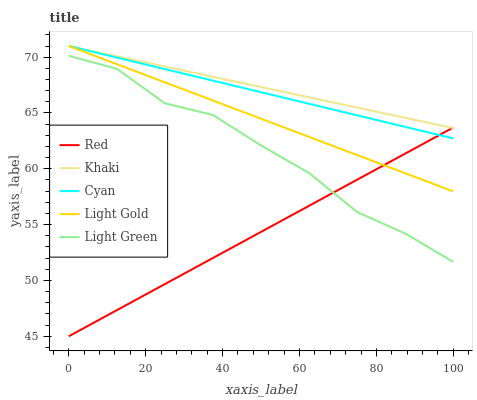Does Red have the minimum area under the curve?
Answer yes or no. Yes. Does Khaki have the maximum area under the curve?
Answer yes or no. Yes. Does Light Gold have the minimum area under the curve?
Answer yes or no. No. Does Light Gold have the maximum area under the curve?
Answer yes or no. No. Is Cyan the smoothest?
Answer yes or no. Yes. Is Light Green the roughest?
Answer yes or no. Yes. Is Khaki the smoothest?
Answer yes or no. No. Is Khaki the roughest?
Answer yes or no. No. Does Red have the lowest value?
Answer yes or no. Yes. Does Light Gold have the lowest value?
Answer yes or no. No. Does Light Gold have the highest value?
Answer yes or no. Yes. Does Light Green have the highest value?
Answer yes or no. No. Is Light Green less than Cyan?
Answer yes or no. Yes. Is Light Gold greater than Light Green?
Answer yes or no. Yes. Does Light Gold intersect Red?
Answer yes or no. Yes. Is Light Gold less than Red?
Answer yes or no. No. Is Light Gold greater than Red?
Answer yes or no. No. Does Light Green intersect Cyan?
Answer yes or no. No. 